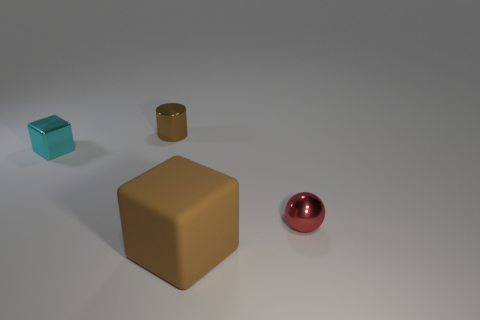What can the various textures and colors in the image tell us about the materials of the objects? The objects exhibit different textures and colors. The larger brown cube has a matte, almost plastic-like texture, while the smaller cyan cube and the gold cylindrical container have a glossier appearance that could suggest metallic qualities. The reddish sphere, with its reflective surface, implies a smooth, possibly metallic or glass material. The diversity of textures and colors indicates a variety of materials within the same scene. 